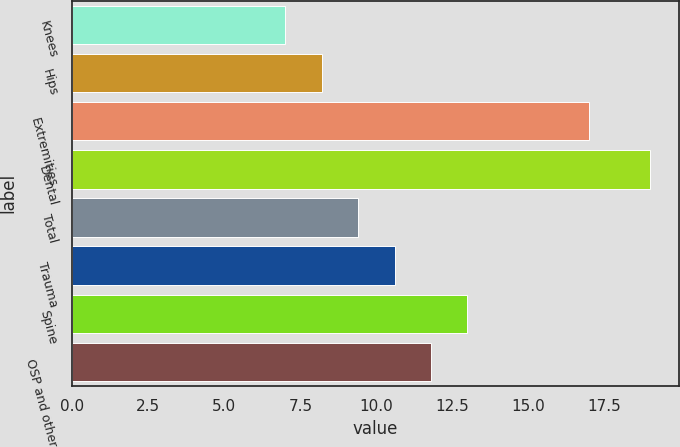Convert chart to OTSL. <chart><loc_0><loc_0><loc_500><loc_500><bar_chart><fcel>Knees<fcel>Hips<fcel>Extremities<fcel>Dental<fcel>Total<fcel>Trauma<fcel>Spine<fcel>OSP and other<nl><fcel>7<fcel>8.2<fcel>17<fcel>19<fcel>9.4<fcel>10.6<fcel>13<fcel>11.8<nl></chart> 